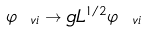<formula> <loc_0><loc_0><loc_500><loc_500>\varphi _ { \ v i } \rightarrow g L ^ { 1 / 2 } \varphi _ { \ v i }</formula> 